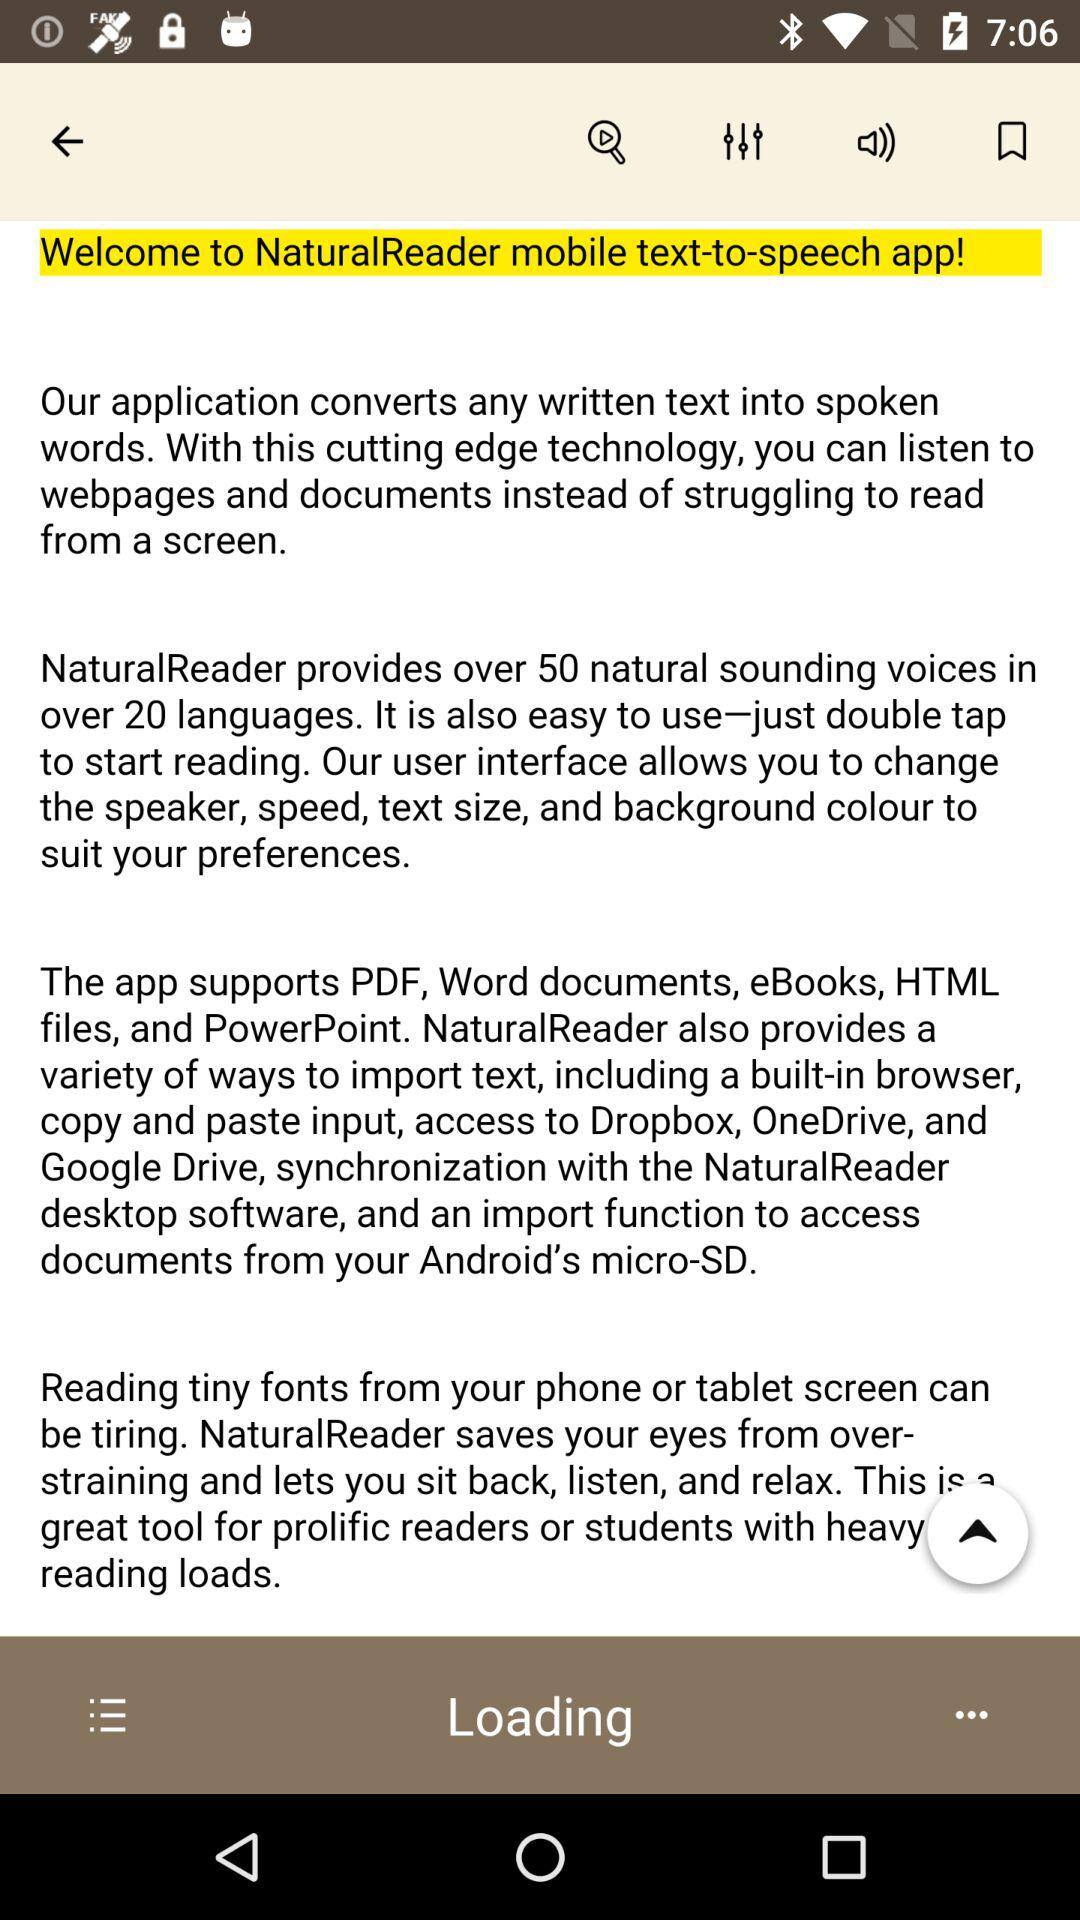How many languages does NaturalReader support?
Answer the question using a single word or phrase. Over 20 